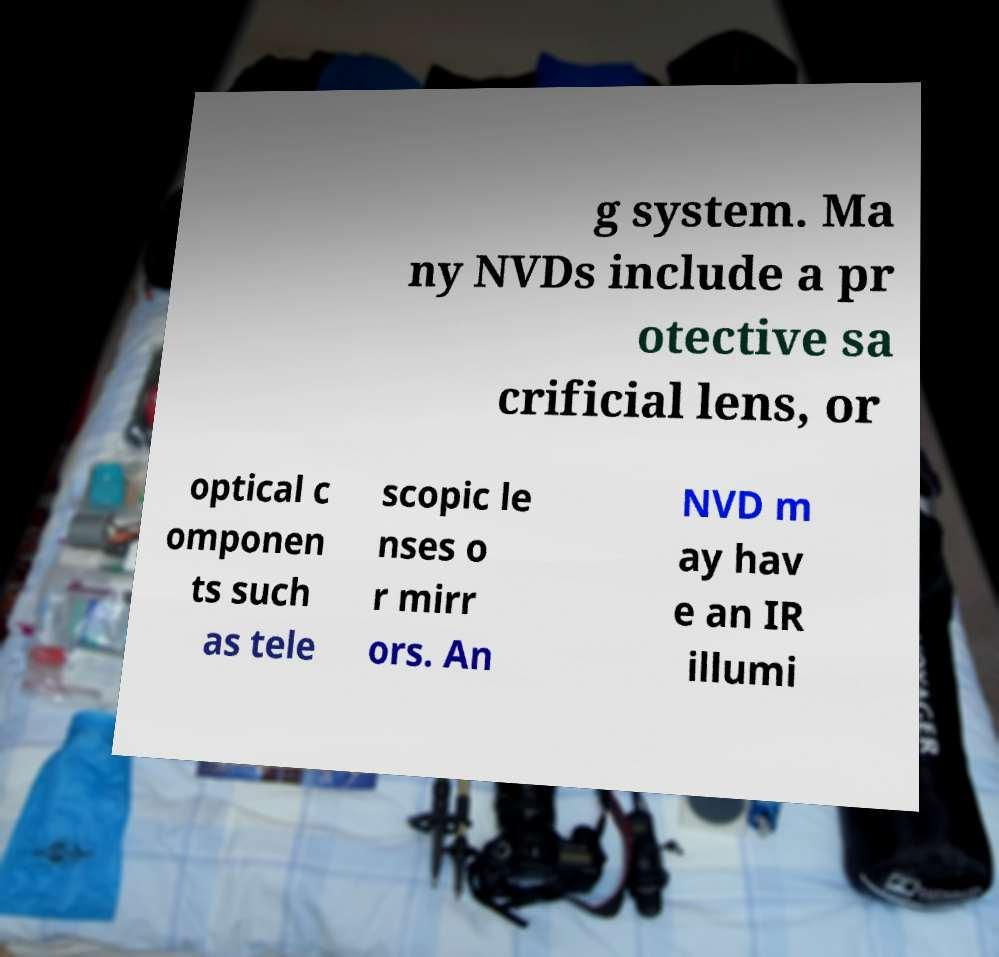Can you accurately transcribe the text from the provided image for me? g system. Ma ny NVDs include a pr otective sa crificial lens, or optical c omponen ts such as tele scopic le nses o r mirr ors. An NVD m ay hav e an IR illumi 